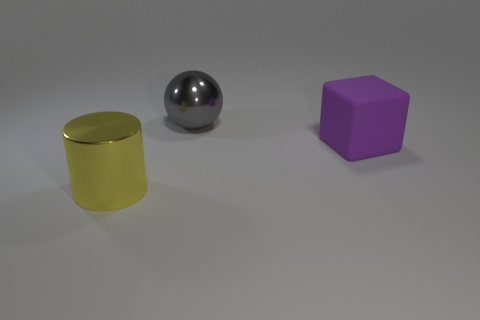The object that is the same material as the sphere is what size?
Make the answer very short. Large. What is the size of the metal thing that is behind the big yellow shiny cylinder left of the big shiny object that is behind the large cube?
Provide a succinct answer. Large. How big is the shiny thing to the right of the yellow metallic cylinder?
Offer a terse response. Large. What number of red things are either large metallic spheres or big rubber spheres?
Keep it short and to the point. 0. Is there a metallic ball of the same size as the gray thing?
Provide a succinct answer. No. There is a yellow cylinder that is the same size as the purple matte block; what is it made of?
Keep it short and to the point. Metal. There is a object right of the metallic sphere; is its size the same as the metal thing that is in front of the large metallic ball?
Ensure brevity in your answer.  Yes. How many objects are either blue metal objects or shiny objects behind the large metal cylinder?
Offer a terse response. 1. Are there any large red rubber things that have the same shape as the large yellow thing?
Give a very brief answer. No. How big is the shiny object that is behind the big cylinder in front of the gray sphere?
Make the answer very short. Large. 